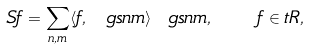<formula> <loc_0><loc_0><loc_500><loc_500>S f = \sum _ { n , m } \langle f , \ g s n m \rangle \ g s n m , \quad f \in \L t R ,</formula> 